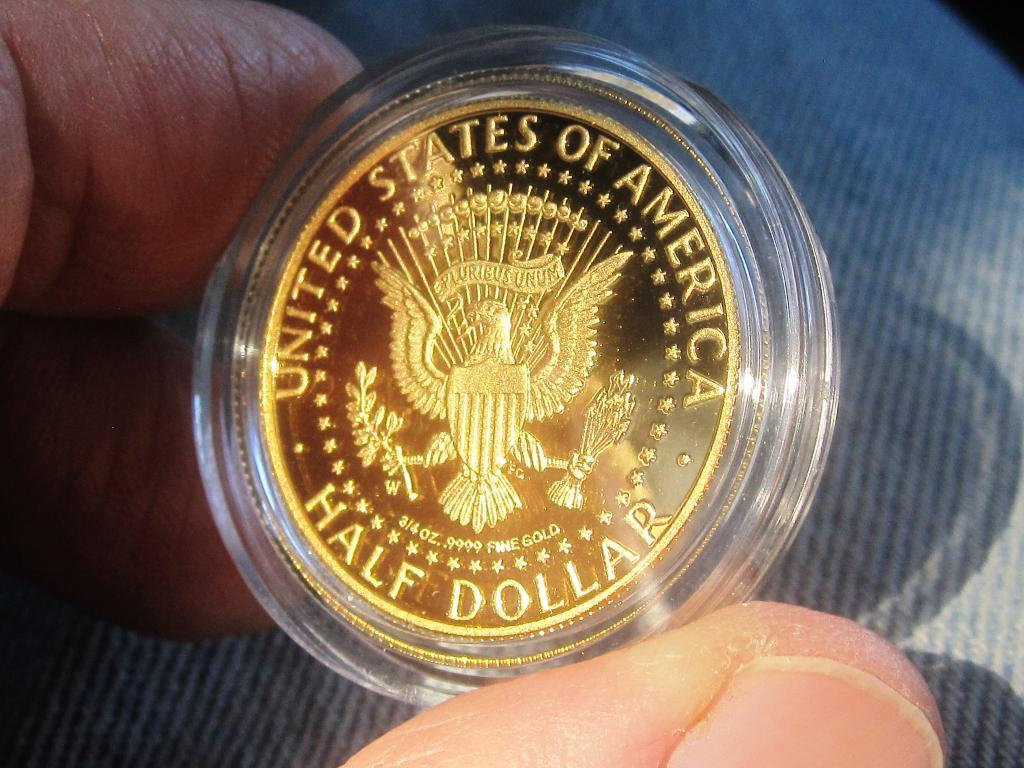<image>
Summarize the visual content of the image. a golden coin that says 'united states of america half dollar' 